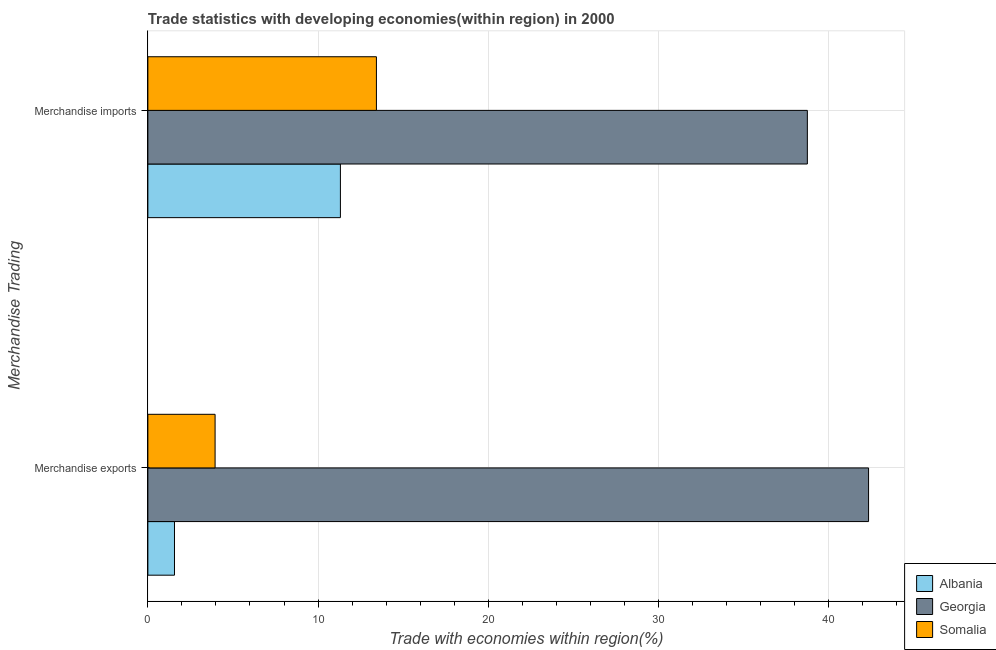How many different coloured bars are there?
Offer a terse response. 3. How many groups of bars are there?
Your answer should be very brief. 2. Are the number of bars per tick equal to the number of legend labels?
Your answer should be very brief. Yes. How many bars are there on the 2nd tick from the bottom?
Your response must be concise. 3. What is the label of the 1st group of bars from the top?
Your answer should be compact. Merchandise imports. What is the merchandise exports in Somalia?
Offer a very short reply. 3.95. Across all countries, what is the maximum merchandise exports?
Provide a short and direct response. 42.34. Across all countries, what is the minimum merchandise exports?
Your answer should be very brief. 1.56. In which country was the merchandise imports maximum?
Provide a succinct answer. Georgia. In which country was the merchandise exports minimum?
Your answer should be very brief. Albania. What is the total merchandise exports in the graph?
Offer a very short reply. 47.86. What is the difference between the merchandise exports in Somalia and that in Georgia?
Offer a very short reply. -38.39. What is the difference between the merchandise exports in Albania and the merchandise imports in Somalia?
Offer a terse response. -11.86. What is the average merchandise exports per country?
Your answer should be compact. 15.95. What is the difference between the merchandise imports and merchandise exports in Somalia?
Ensure brevity in your answer.  9.48. What is the ratio of the merchandise exports in Somalia to that in Albania?
Make the answer very short. 2.52. In how many countries, is the merchandise exports greater than the average merchandise exports taken over all countries?
Provide a succinct answer. 1. What does the 2nd bar from the top in Merchandise exports represents?
Offer a terse response. Georgia. What does the 3rd bar from the bottom in Merchandise exports represents?
Provide a succinct answer. Somalia. How many bars are there?
Your answer should be very brief. 6. What is the difference between two consecutive major ticks on the X-axis?
Keep it short and to the point. 10. Are the values on the major ticks of X-axis written in scientific E-notation?
Your answer should be compact. No. Does the graph contain any zero values?
Give a very brief answer. No. Does the graph contain grids?
Provide a short and direct response. Yes. Where does the legend appear in the graph?
Offer a terse response. Bottom right. What is the title of the graph?
Make the answer very short. Trade statistics with developing economies(within region) in 2000. Does "Mauritania" appear as one of the legend labels in the graph?
Provide a short and direct response. No. What is the label or title of the X-axis?
Give a very brief answer. Trade with economies within region(%). What is the label or title of the Y-axis?
Your response must be concise. Merchandise Trading. What is the Trade with economies within region(%) in Albania in Merchandise exports?
Your answer should be compact. 1.56. What is the Trade with economies within region(%) in Georgia in Merchandise exports?
Your answer should be compact. 42.34. What is the Trade with economies within region(%) in Somalia in Merchandise exports?
Ensure brevity in your answer.  3.95. What is the Trade with economies within region(%) in Albania in Merchandise imports?
Provide a short and direct response. 11.31. What is the Trade with economies within region(%) of Georgia in Merchandise imports?
Give a very brief answer. 38.75. What is the Trade with economies within region(%) in Somalia in Merchandise imports?
Your response must be concise. 13.43. Across all Merchandise Trading, what is the maximum Trade with economies within region(%) of Albania?
Provide a succinct answer. 11.31. Across all Merchandise Trading, what is the maximum Trade with economies within region(%) in Georgia?
Ensure brevity in your answer.  42.34. Across all Merchandise Trading, what is the maximum Trade with economies within region(%) of Somalia?
Offer a terse response. 13.43. Across all Merchandise Trading, what is the minimum Trade with economies within region(%) of Albania?
Your response must be concise. 1.56. Across all Merchandise Trading, what is the minimum Trade with economies within region(%) of Georgia?
Make the answer very short. 38.75. Across all Merchandise Trading, what is the minimum Trade with economies within region(%) of Somalia?
Ensure brevity in your answer.  3.95. What is the total Trade with economies within region(%) in Albania in the graph?
Offer a very short reply. 12.88. What is the total Trade with economies within region(%) in Georgia in the graph?
Ensure brevity in your answer.  81.09. What is the total Trade with economies within region(%) in Somalia in the graph?
Ensure brevity in your answer.  17.38. What is the difference between the Trade with economies within region(%) of Albania in Merchandise exports and that in Merchandise imports?
Your answer should be compact. -9.75. What is the difference between the Trade with economies within region(%) of Georgia in Merchandise exports and that in Merchandise imports?
Your response must be concise. 3.6. What is the difference between the Trade with economies within region(%) in Somalia in Merchandise exports and that in Merchandise imports?
Provide a succinct answer. -9.48. What is the difference between the Trade with economies within region(%) of Albania in Merchandise exports and the Trade with economies within region(%) of Georgia in Merchandise imports?
Give a very brief answer. -37.18. What is the difference between the Trade with economies within region(%) of Albania in Merchandise exports and the Trade with economies within region(%) of Somalia in Merchandise imports?
Make the answer very short. -11.86. What is the difference between the Trade with economies within region(%) in Georgia in Merchandise exports and the Trade with economies within region(%) in Somalia in Merchandise imports?
Offer a terse response. 28.92. What is the average Trade with economies within region(%) of Albania per Merchandise Trading?
Your response must be concise. 6.44. What is the average Trade with economies within region(%) in Georgia per Merchandise Trading?
Your answer should be compact. 40.55. What is the average Trade with economies within region(%) in Somalia per Merchandise Trading?
Your response must be concise. 8.69. What is the difference between the Trade with economies within region(%) of Albania and Trade with economies within region(%) of Georgia in Merchandise exports?
Provide a short and direct response. -40.78. What is the difference between the Trade with economies within region(%) in Albania and Trade with economies within region(%) in Somalia in Merchandise exports?
Your answer should be compact. -2.39. What is the difference between the Trade with economies within region(%) of Georgia and Trade with economies within region(%) of Somalia in Merchandise exports?
Your answer should be very brief. 38.39. What is the difference between the Trade with economies within region(%) of Albania and Trade with economies within region(%) of Georgia in Merchandise imports?
Your answer should be compact. -27.44. What is the difference between the Trade with economies within region(%) in Albania and Trade with economies within region(%) in Somalia in Merchandise imports?
Keep it short and to the point. -2.12. What is the difference between the Trade with economies within region(%) of Georgia and Trade with economies within region(%) of Somalia in Merchandise imports?
Your answer should be compact. 25.32. What is the ratio of the Trade with economies within region(%) of Albania in Merchandise exports to that in Merchandise imports?
Provide a short and direct response. 0.14. What is the ratio of the Trade with economies within region(%) in Georgia in Merchandise exports to that in Merchandise imports?
Your answer should be compact. 1.09. What is the ratio of the Trade with economies within region(%) in Somalia in Merchandise exports to that in Merchandise imports?
Provide a short and direct response. 0.29. What is the difference between the highest and the second highest Trade with economies within region(%) in Albania?
Offer a very short reply. 9.75. What is the difference between the highest and the second highest Trade with economies within region(%) of Georgia?
Provide a succinct answer. 3.6. What is the difference between the highest and the second highest Trade with economies within region(%) of Somalia?
Give a very brief answer. 9.48. What is the difference between the highest and the lowest Trade with economies within region(%) of Albania?
Your answer should be very brief. 9.75. What is the difference between the highest and the lowest Trade with economies within region(%) in Georgia?
Your response must be concise. 3.6. What is the difference between the highest and the lowest Trade with economies within region(%) in Somalia?
Provide a succinct answer. 9.48. 